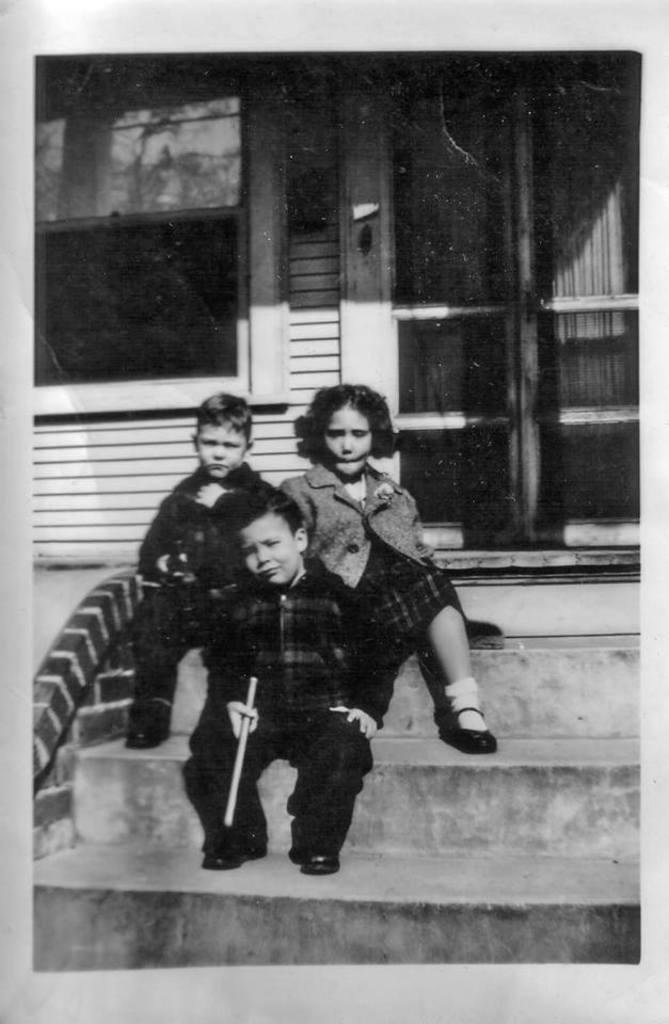How many children are in the image? There are three children in the foreground of the image. What are the children doing in the image? The children are sitting on steps. What architectural features can be seen in the image? There is a door and a window visible in the image. How many letters are the babies holding in the image? There are no babies present in the image, and therefore no letters can be observed. 